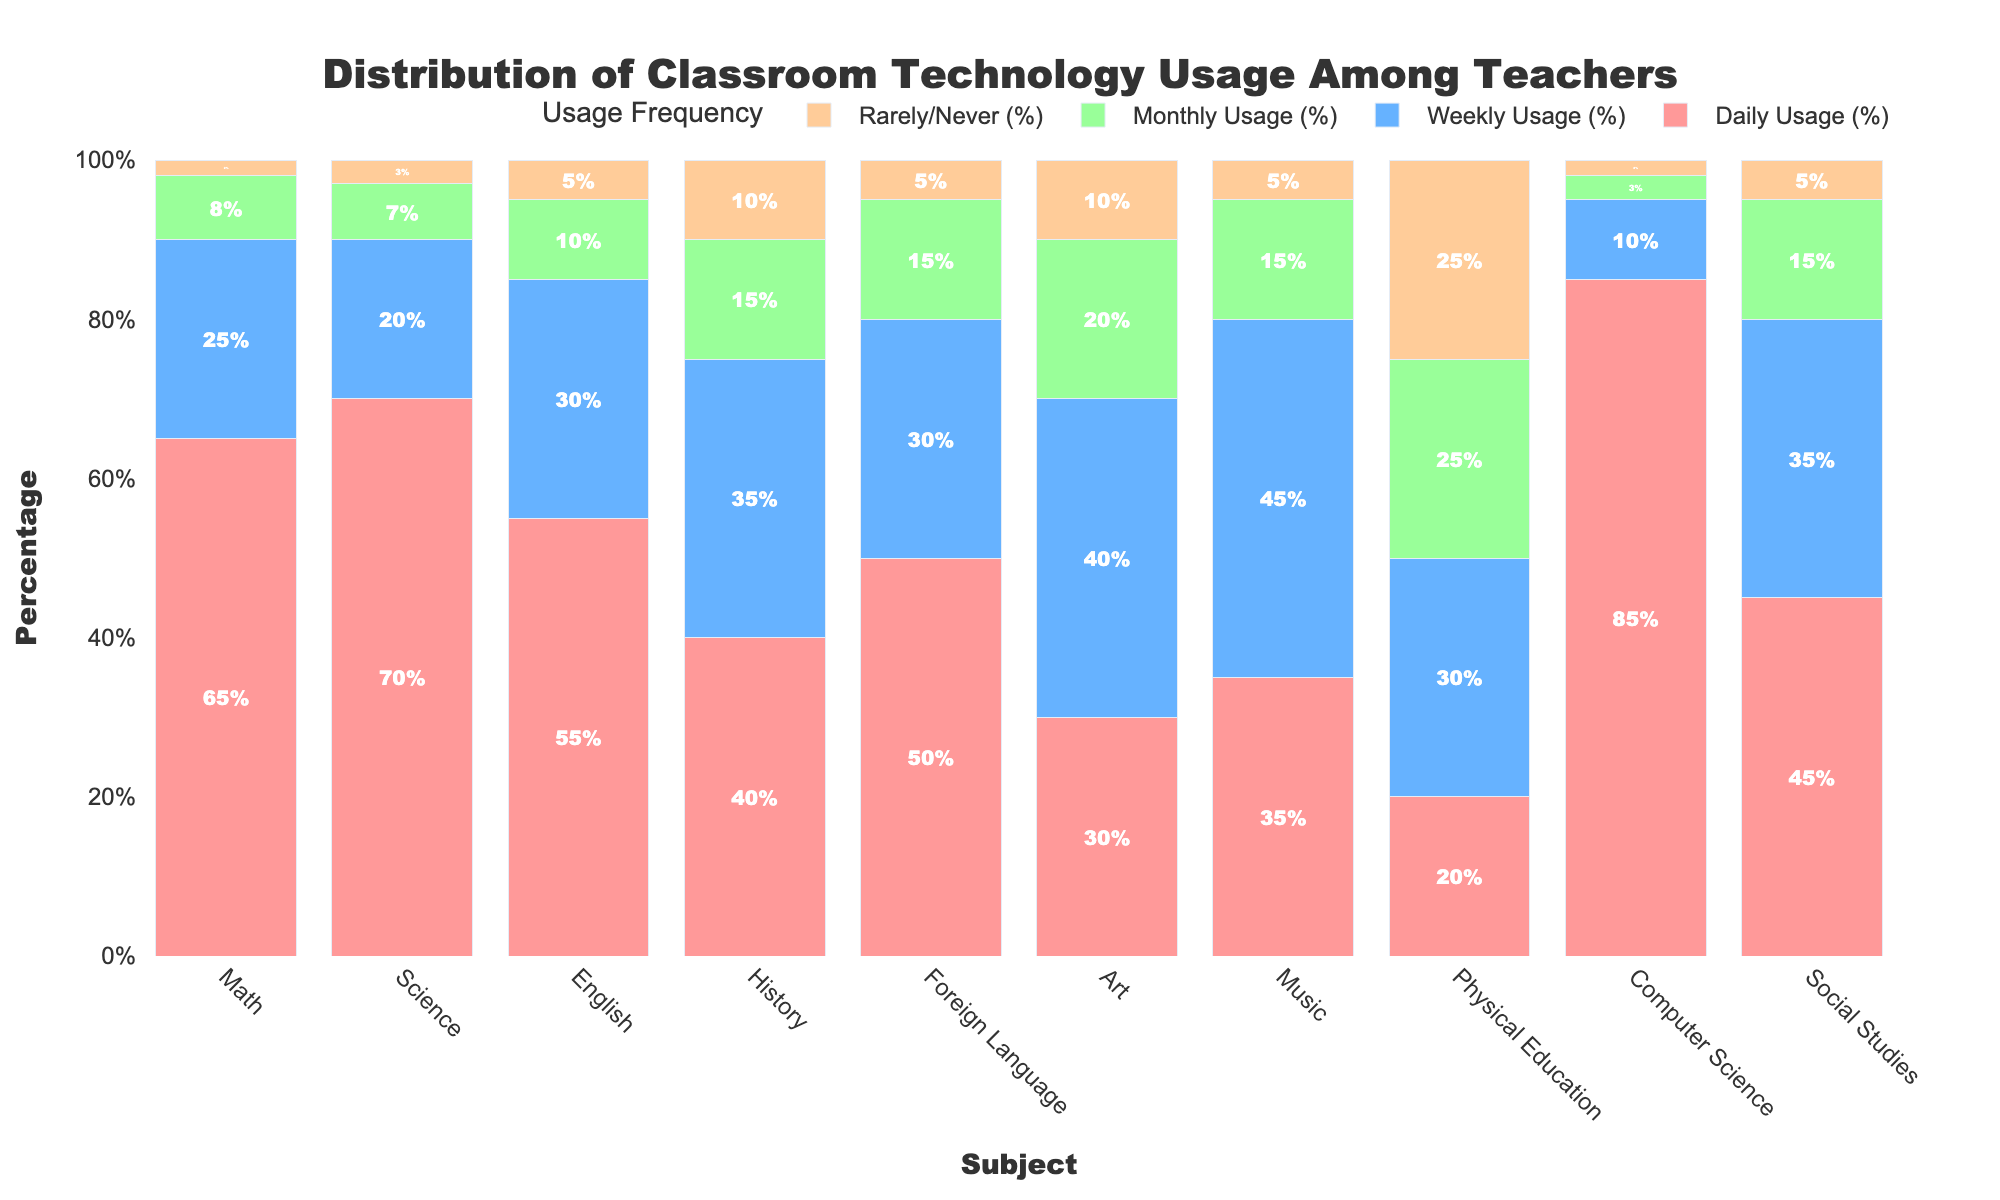What subject areas have more than 50% daily technology usage? Look at the bars labeled 'Daily Usage' for each subject and identify the ones that exceed the 50% mark. Math (65%), Science (70%), English (55%), and Computer Science (85%) all have daily usage over 50%.
Answer: Math, Science, English, Computer Science Which subject has the highest percentage of rarely/never usage? Inspect the 'Rarely/Never' usage bars and find the tallest one. Physical Education has the highest 'Rarely/Never' usage at 25%.
Answer: Physical Education How does the weekly usage percentage of Music compare to that of Art? Examine the 'Weekly Usage' bars for both subjects. Music has 45% weekly usage, while Art has 40%. Comparatively, Music has a higher weekly usage.
Answer: Music has higher weekly usage What is the difference in daily usage between Computer Science and Art? Compare the 'Daily Usage' bars for both subjects. Computer Science has 85% daily usage, and Art has 30%, the difference being 85% - 30%.
Answer: 55% Which subject has the smallest combined percentage for daily and weekly usage? Add the percentages of daily and weekly usage for each subject and find the smallest sum. Physical Education has 20% daily and 30% weekly usage, (20% + 30% = 50%), which is the smallest combined percentage.
Answer: Physical Education Are there any subjects where the combined percentage of monthly and rarely/never usage exceeds 30%? Sum the 'Monthly' and 'Rarely/Never' usage percentages and check if any exceed 30%. For History, Monthly (15%) + Rarely/Never (10%) = 25%. For Art, Monthly (20%) + Rarely/Never (10%) = 30%. For Music, Monthly (15%) + Rarely/Never (5%) = 20%. For Physical Education, Monthly (25%) + Rarely/Never (25%) = 50%. Therefore, Physical Education exceeds 30%.
Answer: Physical Education What is the sum of the monthly usage percentages for the subjects with the lowest and highest daily usages? Determine the subjects with the lowest and highest daily usage (Physical Education 20%, Computer Science 85%). Sum their monthly usage percentages: Physical Education (25%) + Computer Science (3%) = 28%.
Answer: 28% Which subject has a higher percentage of monthly usage, Foreign Language or History? Look at the 'Monthly Usage' bars. Foreign Language has 15%, and History has 15%; both have the same percentage.
Answer: Equal What percentage of teachers in Social Studies rarely or never use technology? Observe the 'Rarely/Never' usage bar for Social Studies. It is at 5%.
Answer: 5% If you group Math, Science, and English together, what is their average daily technology usage? Add the daily usage percentages for Math, Science, and English, then divide by 3: (65% + 70% + 55%) / 3 = 63.33%.
Answer: 63.33% 